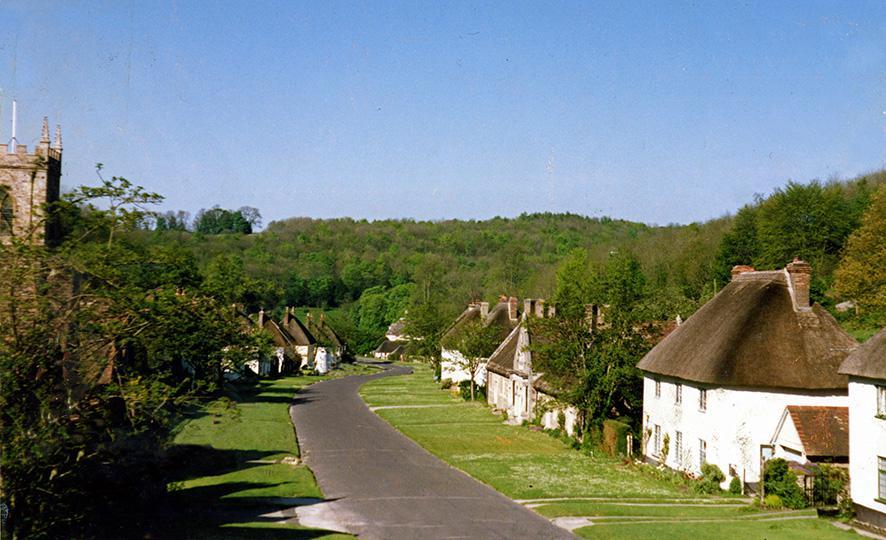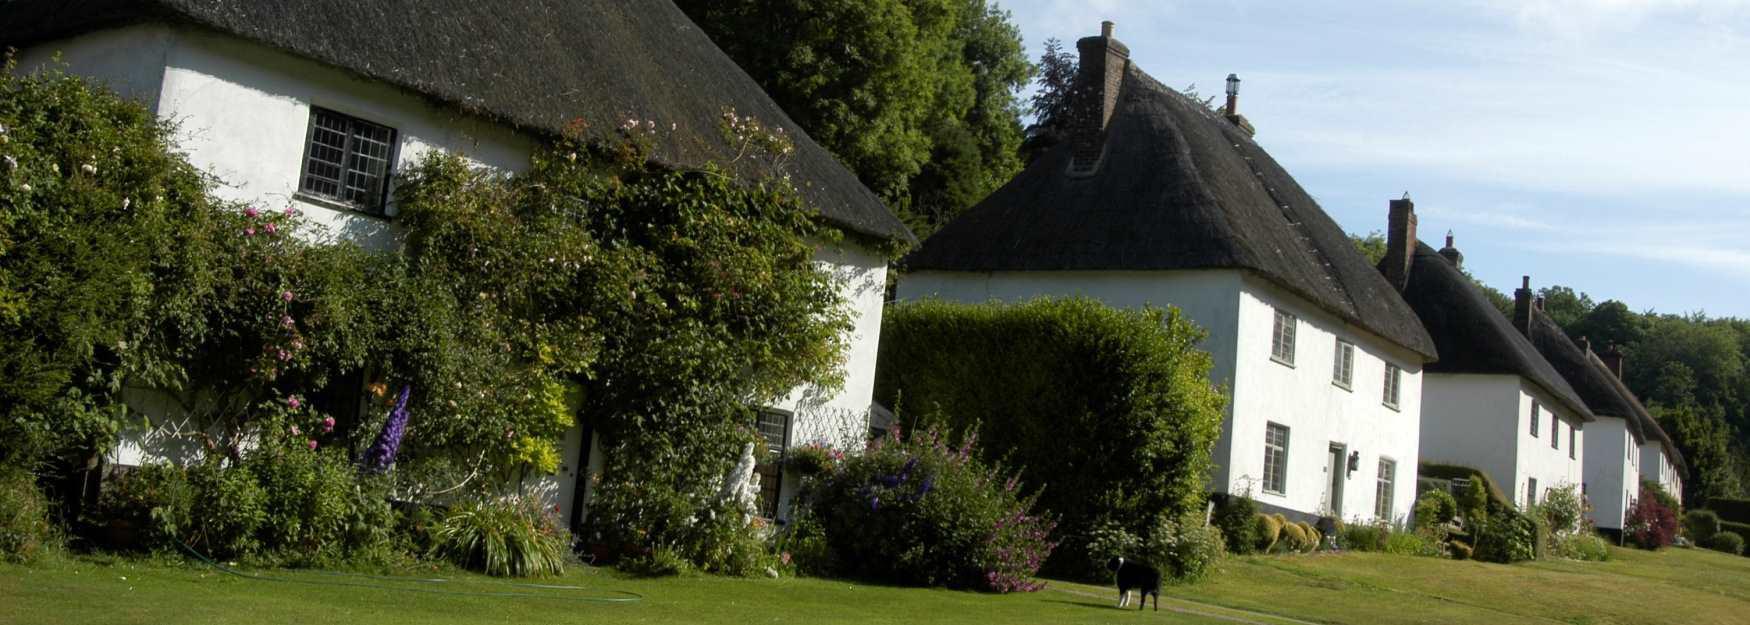The first image is the image on the left, the second image is the image on the right. For the images shown, is this caption "A street passes near a row of houses in the image on the left." true? Answer yes or no. Yes. The first image is the image on the left, the second image is the image on the right. Assess this claim about the two images: "One image shows a row of at least four rectangular white buildings with dark gray roofs to the left of a paved road, and the other image shows one rectangular white building with a dark gray roof.". Correct or not? Answer yes or no. No. 